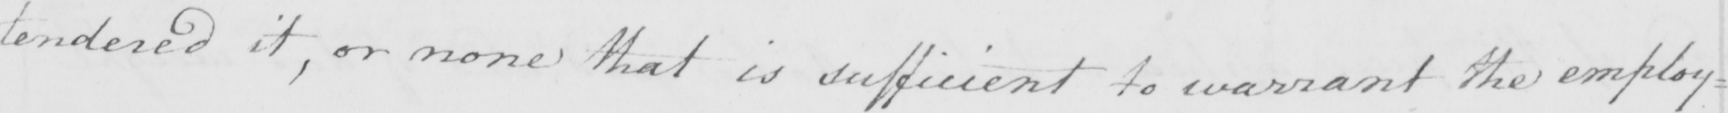What is written in this line of handwriting? tendered it , or none that is sufficient to warrant the employ= 